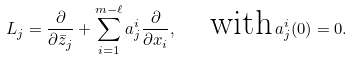Convert formula to latex. <formula><loc_0><loc_0><loc_500><loc_500>L _ { j } = \frac { \partial } { \partial \bar { z } _ { j } } + \sum _ { i = 1 } ^ { m - \ell } a _ { j } ^ { i } \frac { \partial } { \partial { x } _ { i } } , \quad \text {with} \, a _ { j } ^ { i } ( 0 ) = 0 .</formula> 